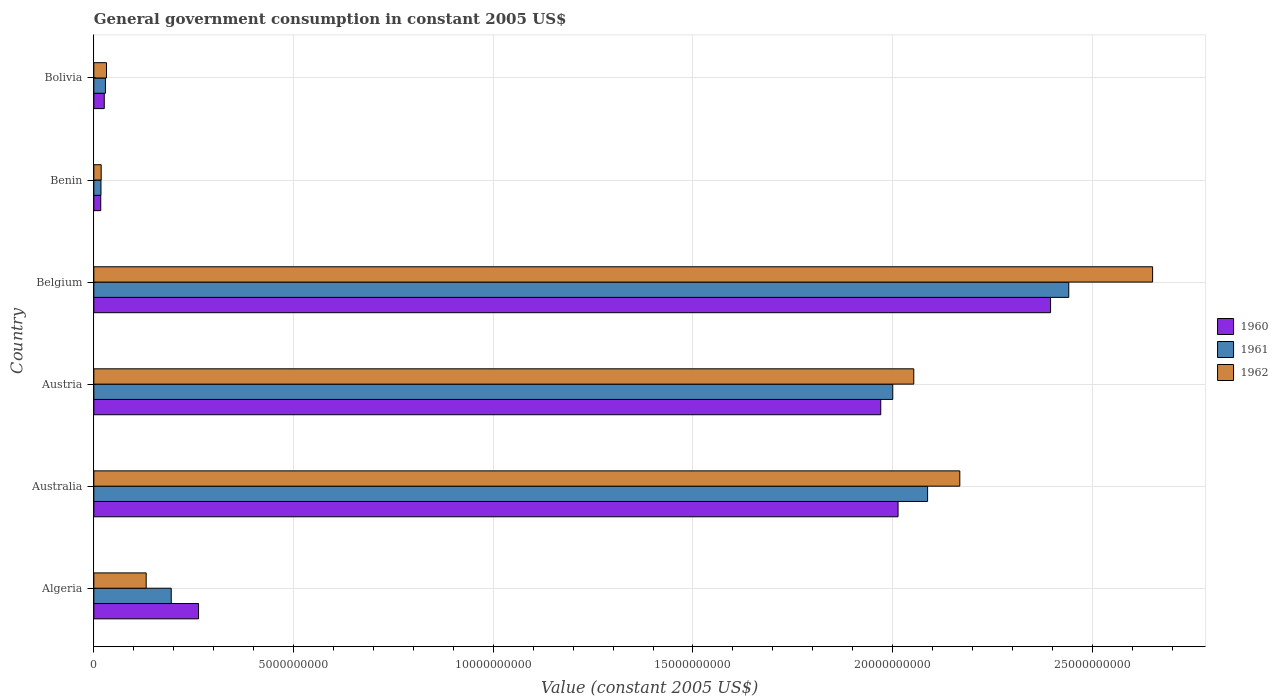How many different coloured bars are there?
Keep it short and to the point. 3. Are the number of bars on each tick of the Y-axis equal?
Offer a very short reply. Yes. How many bars are there on the 2nd tick from the top?
Your response must be concise. 3. How many bars are there on the 2nd tick from the bottom?
Provide a short and direct response. 3. What is the government conusmption in 1962 in Benin?
Offer a terse response. 1.85e+08. Across all countries, what is the maximum government conusmption in 1960?
Provide a succinct answer. 2.40e+1. Across all countries, what is the minimum government conusmption in 1960?
Make the answer very short. 1.73e+08. In which country was the government conusmption in 1961 maximum?
Keep it short and to the point. Belgium. In which country was the government conusmption in 1962 minimum?
Provide a succinct answer. Benin. What is the total government conusmption in 1961 in the graph?
Offer a very short reply. 6.77e+1. What is the difference between the government conusmption in 1962 in Australia and that in Austria?
Give a very brief answer. 1.15e+09. What is the difference between the government conusmption in 1961 in Bolivia and the government conusmption in 1960 in Benin?
Your answer should be very brief. 1.17e+08. What is the average government conusmption in 1960 per country?
Give a very brief answer. 1.11e+1. What is the difference between the government conusmption in 1962 and government conusmption in 1960 in Australia?
Give a very brief answer. 1.55e+09. What is the ratio of the government conusmption in 1962 in Austria to that in Belgium?
Your response must be concise. 0.77. Is the government conusmption in 1960 in Benin less than that in Bolivia?
Your answer should be compact. Yes. What is the difference between the highest and the second highest government conusmption in 1961?
Offer a terse response. 3.53e+09. What is the difference between the highest and the lowest government conusmption in 1962?
Keep it short and to the point. 2.63e+1. What does the 3rd bar from the top in Algeria represents?
Make the answer very short. 1960. What does the 2nd bar from the bottom in Belgium represents?
Provide a succinct answer. 1961. Is it the case that in every country, the sum of the government conusmption in 1961 and government conusmption in 1962 is greater than the government conusmption in 1960?
Offer a very short reply. Yes. How many bars are there?
Make the answer very short. 18. How many countries are there in the graph?
Give a very brief answer. 6. Are the values on the major ticks of X-axis written in scientific E-notation?
Your answer should be compact. No. Does the graph contain any zero values?
Your response must be concise. No. Does the graph contain grids?
Your response must be concise. Yes. How are the legend labels stacked?
Your answer should be very brief. Vertical. What is the title of the graph?
Your response must be concise. General government consumption in constant 2005 US$. What is the label or title of the X-axis?
Your response must be concise. Value (constant 2005 US$). What is the label or title of the Y-axis?
Your response must be concise. Country. What is the Value (constant 2005 US$) in 1960 in Algeria?
Provide a succinct answer. 2.62e+09. What is the Value (constant 2005 US$) in 1961 in Algeria?
Offer a very short reply. 1.94e+09. What is the Value (constant 2005 US$) of 1962 in Algeria?
Your answer should be compact. 1.31e+09. What is the Value (constant 2005 US$) in 1960 in Australia?
Make the answer very short. 2.01e+1. What is the Value (constant 2005 US$) of 1961 in Australia?
Offer a very short reply. 2.09e+1. What is the Value (constant 2005 US$) of 1962 in Australia?
Give a very brief answer. 2.17e+1. What is the Value (constant 2005 US$) of 1960 in Austria?
Your answer should be very brief. 1.97e+1. What is the Value (constant 2005 US$) of 1961 in Austria?
Offer a very short reply. 2.00e+1. What is the Value (constant 2005 US$) in 1962 in Austria?
Your answer should be compact. 2.05e+1. What is the Value (constant 2005 US$) in 1960 in Belgium?
Your response must be concise. 2.40e+1. What is the Value (constant 2005 US$) of 1961 in Belgium?
Make the answer very short. 2.44e+1. What is the Value (constant 2005 US$) of 1962 in Belgium?
Offer a terse response. 2.65e+1. What is the Value (constant 2005 US$) of 1960 in Benin?
Offer a very short reply. 1.73e+08. What is the Value (constant 2005 US$) in 1961 in Benin?
Your answer should be compact. 1.79e+08. What is the Value (constant 2005 US$) in 1962 in Benin?
Offer a very short reply. 1.85e+08. What is the Value (constant 2005 US$) in 1960 in Bolivia?
Offer a terse response. 2.61e+08. What is the Value (constant 2005 US$) in 1961 in Bolivia?
Your answer should be compact. 2.91e+08. What is the Value (constant 2005 US$) in 1962 in Bolivia?
Ensure brevity in your answer.  3.18e+08. Across all countries, what is the maximum Value (constant 2005 US$) in 1960?
Your response must be concise. 2.40e+1. Across all countries, what is the maximum Value (constant 2005 US$) of 1961?
Provide a short and direct response. 2.44e+1. Across all countries, what is the maximum Value (constant 2005 US$) in 1962?
Give a very brief answer. 2.65e+1. Across all countries, what is the minimum Value (constant 2005 US$) in 1960?
Provide a short and direct response. 1.73e+08. Across all countries, what is the minimum Value (constant 2005 US$) of 1961?
Provide a short and direct response. 1.79e+08. Across all countries, what is the minimum Value (constant 2005 US$) of 1962?
Offer a very short reply. 1.85e+08. What is the total Value (constant 2005 US$) of 1960 in the graph?
Your answer should be compact. 6.68e+1. What is the total Value (constant 2005 US$) in 1961 in the graph?
Your answer should be very brief. 6.77e+1. What is the total Value (constant 2005 US$) of 1962 in the graph?
Your response must be concise. 7.05e+1. What is the difference between the Value (constant 2005 US$) in 1960 in Algeria and that in Australia?
Your answer should be compact. -1.75e+1. What is the difference between the Value (constant 2005 US$) of 1961 in Algeria and that in Australia?
Your answer should be compact. -1.89e+1. What is the difference between the Value (constant 2005 US$) in 1962 in Algeria and that in Australia?
Provide a short and direct response. -2.04e+1. What is the difference between the Value (constant 2005 US$) in 1960 in Algeria and that in Austria?
Your response must be concise. -1.71e+1. What is the difference between the Value (constant 2005 US$) of 1961 in Algeria and that in Austria?
Make the answer very short. -1.81e+1. What is the difference between the Value (constant 2005 US$) of 1962 in Algeria and that in Austria?
Your answer should be compact. -1.92e+1. What is the difference between the Value (constant 2005 US$) of 1960 in Algeria and that in Belgium?
Ensure brevity in your answer.  -2.13e+1. What is the difference between the Value (constant 2005 US$) of 1961 in Algeria and that in Belgium?
Your response must be concise. -2.25e+1. What is the difference between the Value (constant 2005 US$) of 1962 in Algeria and that in Belgium?
Keep it short and to the point. -2.52e+1. What is the difference between the Value (constant 2005 US$) in 1960 in Algeria and that in Benin?
Your answer should be very brief. 2.45e+09. What is the difference between the Value (constant 2005 US$) of 1961 in Algeria and that in Benin?
Provide a short and direct response. 1.76e+09. What is the difference between the Value (constant 2005 US$) in 1962 in Algeria and that in Benin?
Provide a succinct answer. 1.13e+09. What is the difference between the Value (constant 2005 US$) in 1960 in Algeria and that in Bolivia?
Provide a short and direct response. 2.36e+09. What is the difference between the Value (constant 2005 US$) in 1961 in Algeria and that in Bolivia?
Your response must be concise. 1.65e+09. What is the difference between the Value (constant 2005 US$) in 1962 in Algeria and that in Bolivia?
Give a very brief answer. 9.93e+08. What is the difference between the Value (constant 2005 US$) in 1960 in Australia and that in Austria?
Make the answer very short. 4.34e+08. What is the difference between the Value (constant 2005 US$) of 1961 in Australia and that in Austria?
Ensure brevity in your answer.  8.72e+08. What is the difference between the Value (constant 2005 US$) in 1962 in Australia and that in Austria?
Ensure brevity in your answer.  1.15e+09. What is the difference between the Value (constant 2005 US$) in 1960 in Australia and that in Belgium?
Your answer should be very brief. -3.82e+09. What is the difference between the Value (constant 2005 US$) of 1961 in Australia and that in Belgium?
Your answer should be compact. -3.53e+09. What is the difference between the Value (constant 2005 US$) of 1962 in Australia and that in Belgium?
Make the answer very short. -4.83e+09. What is the difference between the Value (constant 2005 US$) of 1960 in Australia and that in Benin?
Your answer should be very brief. 2.00e+1. What is the difference between the Value (constant 2005 US$) of 1961 in Australia and that in Benin?
Ensure brevity in your answer.  2.07e+1. What is the difference between the Value (constant 2005 US$) in 1962 in Australia and that in Benin?
Provide a succinct answer. 2.15e+1. What is the difference between the Value (constant 2005 US$) of 1960 in Australia and that in Bolivia?
Provide a succinct answer. 1.99e+1. What is the difference between the Value (constant 2005 US$) in 1961 in Australia and that in Bolivia?
Your response must be concise. 2.06e+1. What is the difference between the Value (constant 2005 US$) of 1962 in Australia and that in Bolivia?
Ensure brevity in your answer.  2.14e+1. What is the difference between the Value (constant 2005 US$) in 1960 in Austria and that in Belgium?
Your answer should be compact. -4.25e+09. What is the difference between the Value (constant 2005 US$) in 1961 in Austria and that in Belgium?
Give a very brief answer. -4.41e+09. What is the difference between the Value (constant 2005 US$) of 1962 in Austria and that in Belgium?
Give a very brief answer. -5.98e+09. What is the difference between the Value (constant 2005 US$) of 1960 in Austria and that in Benin?
Give a very brief answer. 1.95e+1. What is the difference between the Value (constant 2005 US$) of 1961 in Austria and that in Benin?
Your response must be concise. 1.98e+1. What is the difference between the Value (constant 2005 US$) of 1962 in Austria and that in Benin?
Give a very brief answer. 2.03e+1. What is the difference between the Value (constant 2005 US$) of 1960 in Austria and that in Bolivia?
Provide a succinct answer. 1.94e+1. What is the difference between the Value (constant 2005 US$) in 1961 in Austria and that in Bolivia?
Keep it short and to the point. 1.97e+1. What is the difference between the Value (constant 2005 US$) in 1962 in Austria and that in Bolivia?
Provide a short and direct response. 2.02e+1. What is the difference between the Value (constant 2005 US$) in 1960 in Belgium and that in Benin?
Ensure brevity in your answer.  2.38e+1. What is the difference between the Value (constant 2005 US$) in 1961 in Belgium and that in Benin?
Provide a short and direct response. 2.42e+1. What is the difference between the Value (constant 2005 US$) in 1962 in Belgium and that in Benin?
Your answer should be compact. 2.63e+1. What is the difference between the Value (constant 2005 US$) in 1960 in Belgium and that in Bolivia?
Provide a succinct answer. 2.37e+1. What is the difference between the Value (constant 2005 US$) of 1961 in Belgium and that in Bolivia?
Give a very brief answer. 2.41e+1. What is the difference between the Value (constant 2005 US$) in 1962 in Belgium and that in Bolivia?
Provide a succinct answer. 2.62e+1. What is the difference between the Value (constant 2005 US$) in 1960 in Benin and that in Bolivia?
Give a very brief answer. -8.81e+07. What is the difference between the Value (constant 2005 US$) of 1961 in Benin and that in Bolivia?
Ensure brevity in your answer.  -1.12e+08. What is the difference between the Value (constant 2005 US$) of 1962 in Benin and that in Bolivia?
Your answer should be compact. -1.33e+08. What is the difference between the Value (constant 2005 US$) of 1960 in Algeria and the Value (constant 2005 US$) of 1961 in Australia?
Give a very brief answer. -1.83e+1. What is the difference between the Value (constant 2005 US$) of 1960 in Algeria and the Value (constant 2005 US$) of 1962 in Australia?
Provide a succinct answer. -1.91e+1. What is the difference between the Value (constant 2005 US$) of 1961 in Algeria and the Value (constant 2005 US$) of 1962 in Australia?
Your answer should be compact. -1.97e+1. What is the difference between the Value (constant 2005 US$) of 1960 in Algeria and the Value (constant 2005 US$) of 1961 in Austria?
Provide a succinct answer. -1.74e+1. What is the difference between the Value (constant 2005 US$) in 1960 in Algeria and the Value (constant 2005 US$) in 1962 in Austria?
Make the answer very short. -1.79e+1. What is the difference between the Value (constant 2005 US$) in 1961 in Algeria and the Value (constant 2005 US$) in 1962 in Austria?
Make the answer very short. -1.86e+1. What is the difference between the Value (constant 2005 US$) of 1960 in Algeria and the Value (constant 2005 US$) of 1961 in Belgium?
Offer a terse response. -2.18e+1. What is the difference between the Value (constant 2005 US$) in 1960 in Algeria and the Value (constant 2005 US$) in 1962 in Belgium?
Offer a very short reply. -2.39e+1. What is the difference between the Value (constant 2005 US$) of 1961 in Algeria and the Value (constant 2005 US$) of 1962 in Belgium?
Offer a terse response. -2.46e+1. What is the difference between the Value (constant 2005 US$) of 1960 in Algeria and the Value (constant 2005 US$) of 1961 in Benin?
Offer a terse response. 2.44e+09. What is the difference between the Value (constant 2005 US$) in 1960 in Algeria and the Value (constant 2005 US$) in 1962 in Benin?
Your answer should be compact. 2.44e+09. What is the difference between the Value (constant 2005 US$) of 1961 in Algeria and the Value (constant 2005 US$) of 1962 in Benin?
Ensure brevity in your answer.  1.75e+09. What is the difference between the Value (constant 2005 US$) in 1960 in Algeria and the Value (constant 2005 US$) in 1961 in Bolivia?
Provide a short and direct response. 2.33e+09. What is the difference between the Value (constant 2005 US$) of 1960 in Algeria and the Value (constant 2005 US$) of 1962 in Bolivia?
Keep it short and to the point. 2.30e+09. What is the difference between the Value (constant 2005 US$) of 1961 in Algeria and the Value (constant 2005 US$) of 1962 in Bolivia?
Your answer should be compact. 1.62e+09. What is the difference between the Value (constant 2005 US$) of 1960 in Australia and the Value (constant 2005 US$) of 1961 in Austria?
Provide a succinct answer. 1.33e+08. What is the difference between the Value (constant 2005 US$) in 1960 in Australia and the Value (constant 2005 US$) in 1962 in Austria?
Ensure brevity in your answer.  -3.94e+08. What is the difference between the Value (constant 2005 US$) in 1961 in Australia and the Value (constant 2005 US$) in 1962 in Austria?
Offer a very short reply. 3.45e+08. What is the difference between the Value (constant 2005 US$) in 1960 in Australia and the Value (constant 2005 US$) in 1961 in Belgium?
Offer a very short reply. -4.27e+09. What is the difference between the Value (constant 2005 US$) of 1960 in Australia and the Value (constant 2005 US$) of 1962 in Belgium?
Give a very brief answer. -6.37e+09. What is the difference between the Value (constant 2005 US$) in 1961 in Australia and the Value (constant 2005 US$) in 1962 in Belgium?
Provide a short and direct response. -5.63e+09. What is the difference between the Value (constant 2005 US$) in 1960 in Australia and the Value (constant 2005 US$) in 1961 in Benin?
Provide a short and direct response. 2.00e+1. What is the difference between the Value (constant 2005 US$) in 1960 in Australia and the Value (constant 2005 US$) in 1962 in Benin?
Offer a very short reply. 2.00e+1. What is the difference between the Value (constant 2005 US$) in 1961 in Australia and the Value (constant 2005 US$) in 1962 in Benin?
Provide a short and direct response. 2.07e+1. What is the difference between the Value (constant 2005 US$) in 1960 in Australia and the Value (constant 2005 US$) in 1961 in Bolivia?
Ensure brevity in your answer.  1.98e+1. What is the difference between the Value (constant 2005 US$) in 1960 in Australia and the Value (constant 2005 US$) in 1962 in Bolivia?
Offer a terse response. 1.98e+1. What is the difference between the Value (constant 2005 US$) of 1961 in Australia and the Value (constant 2005 US$) of 1962 in Bolivia?
Keep it short and to the point. 2.06e+1. What is the difference between the Value (constant 2005 US$) in 1960 in Austria and the Value (constant 2005 US$) in 1961 in Belgium?
Give a very brief answer. -4.71e+09. What is the difference between the Value (constant 2005 US$) of 1960 in Austria and the Value (constant 2005 US$) of 1962 in Belgium?
Keep it short and to the point. -6.81e+09. What is the difference between the Value (constant 2005 US$) in 1961 in Austria and the Value (constant 2005 US$) in 1962 in Belgium?
Your answer should be very brief. -6.51e+09. What is the difference between the Value (constant 2005 US$) in 1960 in Austria and the Value (constant 2005 US$) in 1961 in Benin?
Your answer should be compact. 1.95e+1. What is the difference between the Value (constant 2005 US$) of 1960 in Austria and the Value (constant 2005 US$) of 1962 in Benin?
Your answer should be very brief. 1.95e+1. What is the difference between the Value (constant 2005 US$) in 1961 in Austria and the Value (constant 2005 US$) in 1962 in Benin?
Ensure brevity in your answer.  1.98e+1. What is the difference between the Value (constant 2005 US$) in 1960 in Austria and the Value (constant 2005 US$) in 1961 in Bolivia?
Keep it short and to the point. 1.94e+1. What is the difference between the Value (constant 2005 US$) of 1960 in Austria and the Value (constant 2005 US$) of 1962 in Bolivia?
Provide a succinct answer. 1.94e+1. What is the difference between the Value (constant 2005 US$) in 1961 in Austria and the Value (constant 2005 US$) in 1962 in Bolivia?
Offer a very short reply. 1.97e+1. What is the difference between the Value (constant 2005 US$) in 1960 in Belgium and the Value (constant 2005 US$) in 1961 in Benin?
Your response must be concise. 2.38e+1. What is the difference between the Value (constant 2005 US$) of 1960 in Belgium and the Value (constant 2005 US$) of 1962 in Benin?
Your response must be concise. 2.38e+1. What is the difference between the Value (constant 2005 US$) of 1961 in Belgium and the Value (constant 2005 US$) of 1962 in Benin?
Your answer should be very brief. 2.42e+1. What is the difference between the Value (constant 2005 US$) in 1960 in Belgium and the Value (constant 2005 US$) in 1961 in Bolivia?
Make the answer very short. 2.37e+1. What is the difference between the Value (constant 2005 US$) in 1960 in Belgium and the Value (constant 2005 US$) in 1962 in Bolivia?
Your answer should be very brief. 2.36e+1. What is the difference between the Value (constant 2005 US$) in 1961 in Belgium and the Value (constant 2005 US$) in 1962 in Bolivia?
Your answer should be compact. 2.41e+1. What is the difference between the Value (constant 2005 US$) of 1960 in Benin and the Value (constant 2005 US$) of 1961 in Bolivia?
Your response must be concise. -1.17e+08. What is the difference between the Value (constant 2005 US$) of 1960 in Benin and the Value (constant 2005 US$) of 1962 in Bolivia?
Make the answer very short. -1.44e+08. What is the difference between the Value (constant 2005 US$) of 1961 in Benin and the Value (constant 2005 US$) of 1962 in Bolivia?
Your answer should be compact. -1.39e+08. What is the average Value (constant 2005 US$) of 1960 per country?
Ensure brevity in your answer.  1.11e+1. What is the average Value (constant 2005 US$) in 1961 per country?
Provide a succinct answer. 1.13e+1. What is the average Value (constant 2005 US$) of 1962 per country?
Your response must be concise. 1.18e+1. What is the difference between the Value (constant 2005 US$) of 1960 and Value (constant 2005 US$) of 1961 in Algeria?
Your answer should be very brief. 6.84e+08. What is the difference between the Value (constant 2005 US$) in 1960 and Value (constant 2005 US$) in 1962 in Algeria?
Keep it short and to the point. 1.31e+09. What is the difference between the Value (constant 2005 US$) of 1961 and Value (constant 2005 US$) of 1962 in Algeria?
Provide a short and direct response. 6.27e+08. What is the difference between the Value (constant 2005 US$) in 1960 and Value (constant 2005 US$) in 1961 in Australia?
Your answer should be very brief. -7.39e+08. What is the difference between the Value (constant 2005 US$) in 1960 and Value (constant 2005 US$) in 1962 in Australia?
Keep it short and to the point. -1.55e+09. What is the difference between the Value (constant 2005 US$) of 1961 and Value (constant 2005 US$) of 1962 in Australia?
Your response must be concise. -8.07e+08. What is the difference between the Value (constant 2005 US$) in 1960 and Value (constant 2005 US$) in 1961 in Austria?
Offer a very short reply. -3.01e+08. What is the difference between the Value (constant 2005 US$) of 1960 and Value (constant 2005 US$) of 1962 in Austria?
Keep it short and to the point. -8.27e+08. What is the difference between the Value (constant 2005 US$) in 1961 and Value (constant 2005 US$) in 1962 in Austria?
Provide a succinct answer. -5.26e+08. What is the difference between the Value (constant 2005 US$) in 1960 and Value (constant 2005 US$) in 1961 in Belgium?
Your response must be concise. -4.56e+08. What is the difference between the Value (constant 2005 US$) in 1960 and Value (constant 2005 US$) in 1962 in Belgium?
Offer a terse response. -2.55e+09. What is the difference between the Value (constant 2005 US$) in 1961 and Value (constant 2005 US$) in 1962 in Belgium?
Your response must be concise. -2.10e+09. What is the difference between the Value (constant 2005 US$) in 1960 and Value (constant 2005 US$) in 1961 in Benin?
Provide a succinct answer. -5.64e+06. What is the difference between the Value (constant 2005 US$) of 1960 and Value (constant 2005 US$) of 1962 in Benin?
Offer a very short reply. -1.13e+07. What is the difference between the Value (constant 2005 US$) in 1961 and Value (constant 2005 US$) in 1962 in Benin?
Give a very brief answer. -5.64e+06. What is the difference between the Value (constant 2005 US$) of 1960 and Value (constant 2005 US$) of 1961 in Bolivia?
Your answer should be very brief. -2.92e+07. What is the difference between the Value (constant 2005 US$) in 1960 and Value (constant 2005 US$) in 1962 in Bolivia?
Offer a terse response. -5.62e+07. What is the difference between the Value (constant 2005 US$) in 1961 and Value (constant 2005 US$) in 1962 in Bolivia?
Ensure brevity in your answer.  -2.70e+07. What is the ratio of the Value (constant 2005 US$) of 1960 in Algeria to that in Australia?
Ensure brevity in your answer.  0.13. What is the ratio of the Value (constant 2005 US$) in 1961 in Algeria to that in Australia?
Keep it short and to the point. 0.09. What is the ratio of the Value (constant 2005 US$) of 1962 in Algeria to that in Australia?
Your answer should be compact. 0.06. What is the ratio of the Value (constant 2005 US$) in 1960 in Algeria to that in Austria?
Your answer should be compact. 0.13. What is the ratio of the Value (constant 2005 US$) of 1961 in Algeria to that in Austria?
Offer a very short reply. 0.1. What is the ratio of the Value (constant 2005 US$) of 1962 in Algeria to that in Austria?
Your answer should be compact. 0.06. What is the ratio of the Value (constant 2005 US$) in 1960 in Algeria to that in Belgium?
Make the answer very short. 0.11. What is the ratio of the Value (constant 2005 US$) in 1961 in Algeria to that in Belgium?
Your answer should be compact. 0.08. What is the ratio of the Value (constant 2005 US$) in 1962 in Algeria to that in Belgium?
Offer a terse response. 0.05. What is the ratio of the Value (constant 2005 US$) in 1960 in Algeria to that in Benin?
Give a very brief answer. 15.13. What is the ratio of the Value (constant 2005 US$) of 1961 in Algeria to that in Benin?
Offer a terse response. 10.83. What is the ratio of the Value (constant 2005 US$) of 1962 in Algeria to that in Benin?
Make the answer very short. 7.1. What is the ratio of the Value (constant 2005 US$) in 1960 in Algeria to that in Bolivia?
Ensure brevity in your answer.  10.03. What is the ratio of the Value (constant 2005 US$) of 1961 in Algeria to that in Bolivia?
Offer a very short reply. 6.67. What is the ratio of the Value (constant 2005 US$) of 1962 in Algeria to that in Bolivia?
Offer a terse response. 4.13. What is the ratio of the Value (constant 2005 US$) in 1961 in Australia to that in Austria?
Provide a succinct answer. 1.04. What is the ratio of the Value (constant 2005 US$) of 1962 in Australia to that in Austria?
Offer a terse response. 1.06. What is the ratio of the Value (constant 2005 US$) in 1960 in Australia to that in Belgium?
Give a very brief answer. 0.84. What is the ratio of the Value (constant 2005 US$) of 1961 in Australia to that in Belgium?
Your answer should be very brief. 0.86. What is the ratio of the Value (constant 2005 US$) in 1962 in Australia to that in Belgium?
Provide a short and direct response. 0.82. What is the ratio of the Value (constant 2005 US$) of 1960 in Australia to that in Benin?
Your answer should be compact. 116.16. What is the ratio of the Value (constant 2005 US$) in 1961 in Australia to that in Benin?
Offer a terse response. 116.63. What is the ratio of the Value (constant 2005 US$) in 1962 in Australia to that in Benin?
Offer a very short reply. 117.44. What is the ratio of the Value (constant 2005 US$) of 1960 in Australia to that in Bolivia?
Offer a very short reply. 77.01. What is the ratio of the Value (constant 2005 US$) in 1961 in Australia to that in Bolivia?
Ensure brevity in your answer.  71.81. What is the ratio of the Value (constant 2005 US$) of 1962 in Australia to that in Bolivia?
Offer a very short reply. 68.25. What is the ratio of the Value (constant 2005 US$) of 1960 in Austria to that in Belgium?
Your answer should be very brief. 0.82. What is the ratio of the Value (constant 2005 US$) in 1961 in Austria to that in Belgium?
Ensure brevity in your answer.  0.82. What is the ratio of the Value (constant 2005 US$) of 1962 in Austria to that in Belgium?
Provide a short and direct response. 0.77. What is the ratio of the Value (constant 2005 US$) of 1960 in Austria to that in Benin?
Make the answer very short. 113.66. What is the ratio of the Value (constant 2005 US$) in 1961 in Austria to that in Benin?
Offer a terse response. 111.76. What is the ratio of the Value (constant 2005 US$) of 1962 in Austria to that in Benin?
Keep it short and to the point. 111.2. What is the ratio of the Value (constant 2005 US$) in 1960 in Austria to that in Bolivia?
Provide a succinct answer. 75.35. What is the ratio of the Value (constant 2005 US$) in 1961 in Austria to that in Bolivia?
Offer a very short reply. 68.81. What is the ratio of the Value (constant 2005 US$) in 1962 in Austria to that in Bolivia?
Keep it short and to the point. 64.62. What is the ratio of the Value (constant 2005 US$) in 1960 in Belgium to that in Benin?
Offer a terse response. 138.18. What is the ratio of the Value (constant 2005 US$) in 1961 in Belgium to that in Benin?
Offer a terse response. 136.38. What is the ratio of the Value (constant 2005 US$) in 1962 in Belgium to that in Benin?
Ensure brevity in your answer.  143.58. What is the ratio of the Value (constant 2005 US$) in 1960 in Belgium to that in Bolivia?
Ensure brevity in your answer.  91.61. What is the ratio of the Value (constant 2005 US$) in 1961 in Belgium to that in Bolivia?
Offer a terse response. 83.97. What is the ratio of the Value (constant 2005 US$) of 1962 in Belgium to that in Bolivia?
Keep it short and to the point. 83.45. What is the ratio of the Value (constant 2005 US$) of 1960 in Benin to that in Bolivia?
Provide a succinct answer. 0.66. What is the ratio of the Value (constant 2005 US$) of 1961 in Benin to that in Bolivia?
Make the answer very short. 0.62. What is the ratio of the Value (constant 2005 US$) of 1962 in Benin to that in Bolivia?
Your response must be concise. 0.58. What is the difference between the highest and the second highest Value (constant 2005 US$) in 1960?
Provide a succinct answer. 3.82e+09. What is the difference between the highest and the second highest Value (constant 2005 US$) in 1961?
Your answer should be compact. 3.53e+09. What is the difference between the highest and the second highest Value (constant 2005 US$) of 1962?
Give a very brief answer. 4.83e+09. What is the difference between the highest and the lowest Value (constant 2005 US$) in 1960?
Offer a terse response. 2.38e+1. What is the difference between the highest and the lowest Value (constant 2005 US$) in 1961?
Provide a short and direct response. 2.42e+1. What is the difference between the highest and the lowest Value (constant 2005 US$) in 1962?
Provide a short and direct response. 2.63e+1. 